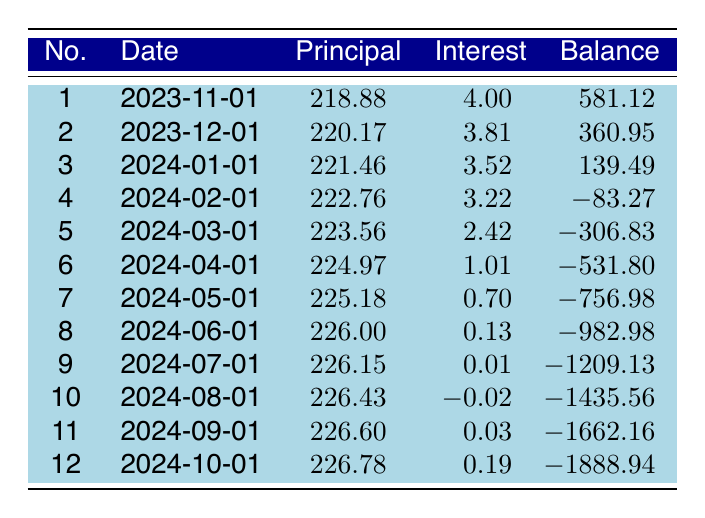What is the total interest paid after the first three payments? To find the total interest paid after the first three payments, we need to sum the interest payments from the first three entries in the table. The interest payments are 4.00, 3.81, and 3.52. Adding these together: 4.00 + 3.81 + 3.52 = 11.33.
Answer: 11.33 How much was the principal payment for the second installment? The principal payment for the second installment is listed directly in the table. It is 220.17.
Answer: 220.17 Is the remaining balance after the fourth payment negative? To answer this, we look at the remaining balance after the fourth payment, which is reported as -83.27. A negative balance means that the loan has been overpaid. Thus, the answer is yes.
Answer: Yes What is the average principal payment for the first six payments? The average principal payment is calculated by finding the sum of the principal payments for the first six payments and then dividing by 6. The payments are 218.88, 220.17, 221.46, 222.76, 223.56, and 224.97. First, add them: 218.88 + 220.17 + 221.46 + 222.76 + 223.56 + 224.97 = 1331.80. Then, divide by 6: 1331.80 / 6 = 221.97.
Answer: 221.97 How much is the total remaining balance after all 12 payments? The remaining balance after all 12 payments is listed as -1888.94 in the table. This value indicates the total overpayment on the loan.
Answer: -1888.94 What is the principal payment for the sixth installment? The principal payment for the sixth installment can be found directly in the table and is 224.97.
Answer: 224.97 Was the interest payment for the tenth installment negative? The interest payment for the tenth installment is shown as -0.02 in the table, which means it was negative. Therefore, the answer is yes.
Answer: Yes How much total principal has been paid after the first five installments? To determine the total principal paid after the first five installments, sum the principal payments for the first five payments: 218.88 + 220.17 + 221.46 + 222.76 + 223.56 = 1106.83.
Answer: 1106.83 